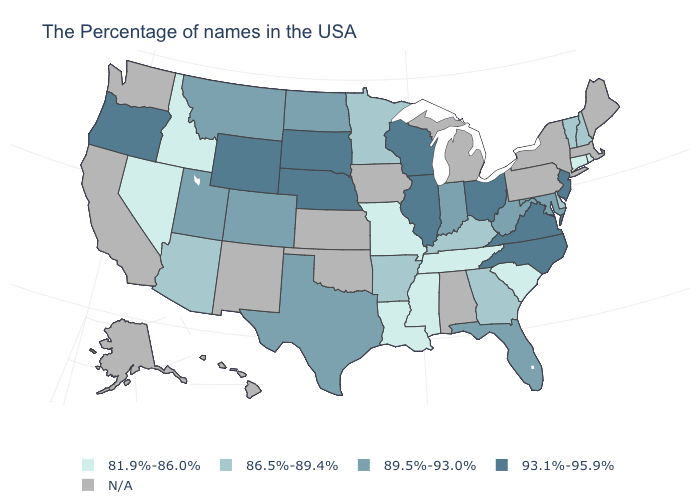Name the states that have a value in the range 86.5%-89.4%?
Concise answer only. New Hampshire, Vermont, Delaware, Georgia, Kentucky, Arkansas, Minnesota, Arizona. How many symbols are there in the legend?
Quick response, please. 5. Does the first symbol in the legend represent the smallest category?
Quick response, please. Yes. What is the highest value in states that border West Virginia?
Answer briefly. 93.1%-95.9%. What is the value of Connecticut?
Be succinct. 81.9%-86.0%. Is the legend a continuous bar?
Answer briefly. No. What is the value of New Hampshire?
Quick response, please. 86.5%-89.4%. What is the highest value in the USA?
Short answer required. 93.1%-95.9%. Which states have the lowest value in the USA?
Be succinct. Rhode Island, Connecticut, South Carolina, Tennessee, Mississippi, Louisiana, Missouri, Idaho, Nevada. Name the states that have a value in the range N/A?
Keep it brief. Maine, Massachusetts, New York, Pennsylvania, Michigan, Alabama, Iowa, Kansas, Oklahoma, New Mexico, California, Washington, Alaska, Hawaii. What is the value of Maryland?
Keep it brief. 89.5%-93.0%. What is the value of Utah?
Answer briefly. 89.5%-93.0%. What is the highest value in states that border Oregon?
Quick response, please. 81.9%-86.0%. Name the states that have a value in the range 93.1%-95.9%?
Concise answer only. New Jersey, Virginia, North Carolina, Ohio, Wisconsin, Illinois, Nebraska, South Dakota, Wyoming, Oregon. What is the value of Maryland?
Give a very brief answer. 89.5%-93.0%. 